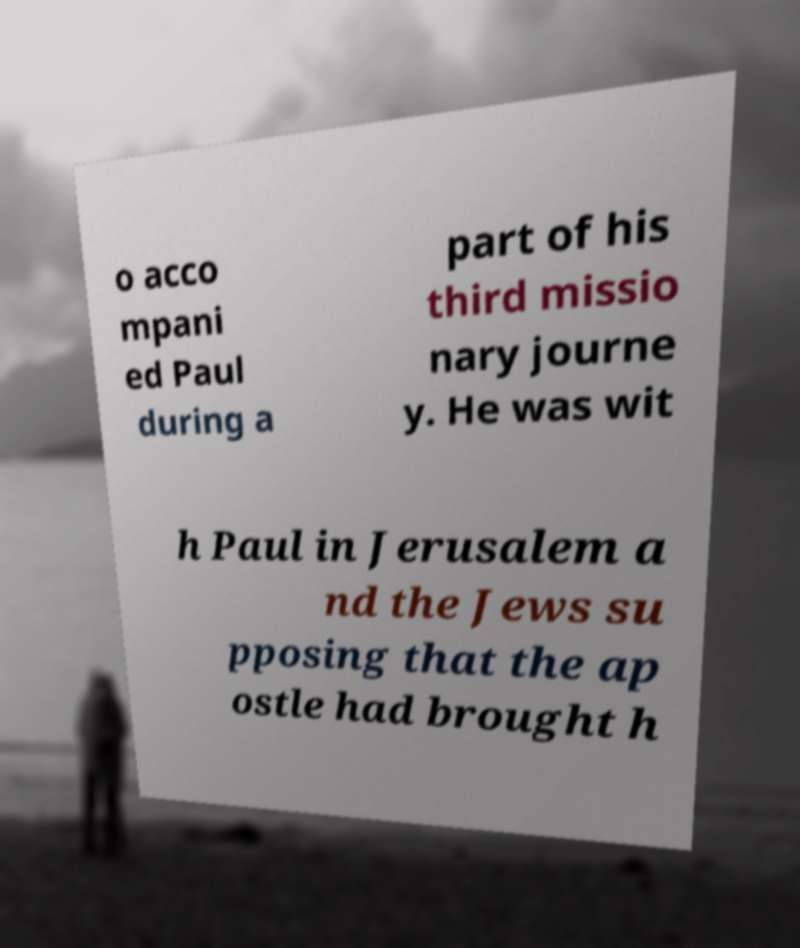Please read and relay the text visible in this image. What does it say? o acco mpani ed Paul during a part of his third missio nary journe y. He was wit h Paul in Jerusalem a nd the Jews su pposing that the ap ostle had brought h 